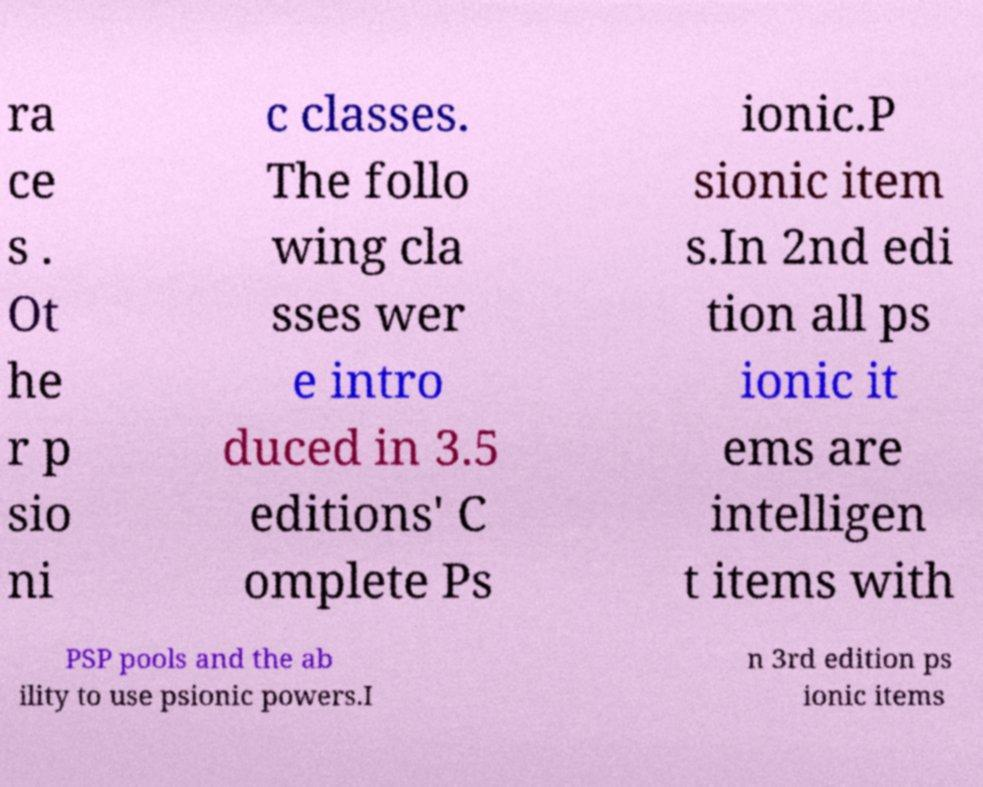Can you read and provide the text displayed in the image?This photo seems to have some interesting text. Can you extract and type it out for me? ra ce s . Ot he r p sio ni c classes. The follo wing cla sses wer e intro duced in 3.5 editions' C omplete Ps ionic.P sionic item s.In 2nd edi tion all ps ionic it ems are intelligen t items with PSP pools and the ab ility to use psionic powers.I n 3rd edition ps ionic items 